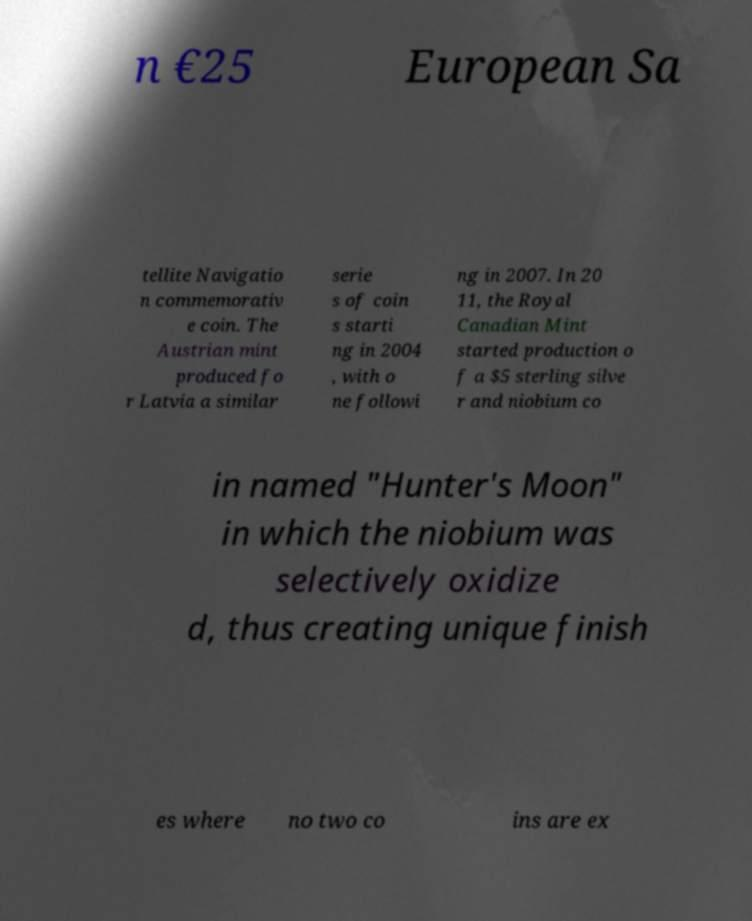Can you accurately transcribe the text from the provided image for me? n €25 European Sa tellite Navigatio n commemorativ e coin. The Austrian mint produced fo r Latvia a similar serie s of coin s starti ng in 2004 , with o ne followi ng in 2007. In 20 11, the Royal Canadian Mint started production o f a $5 sterling silve r and niobium co in named "Hunter's Moon" in which the niobium was selectively oxidize d, thus creating unique finish es where no two co ins are ex 